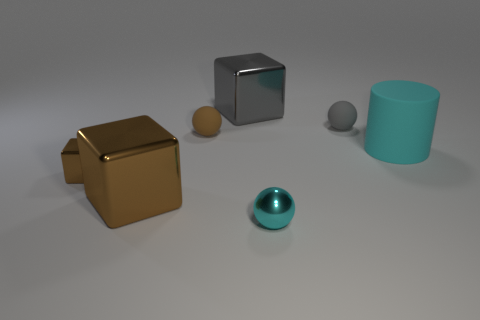Subtract all matte balls. How many balls are left? 1 Subtract all cyan cylinders. How many brown blocks are left? 2 Subtract all brown cubes. How many cubes are left? 1 Add 1 small yellow cylinders. How many objects exist? 8 Subtract 1 cylinders. How many cylinders are left? 0 Subtract all cylinders. How many objects are left? 6 Subtract all red cubes. Subtract all cyan cylinders. How many cubes are left? 3 Subtract all cyan cylinders. Subtract all tiny brown blocks. How many objects are left? 5 Add 6 tiny cyan shiny spheres. How many tiny cyan shiny spheres are left? 7 Add 4 big blue cubes. How many big blue cubes exist? 4 